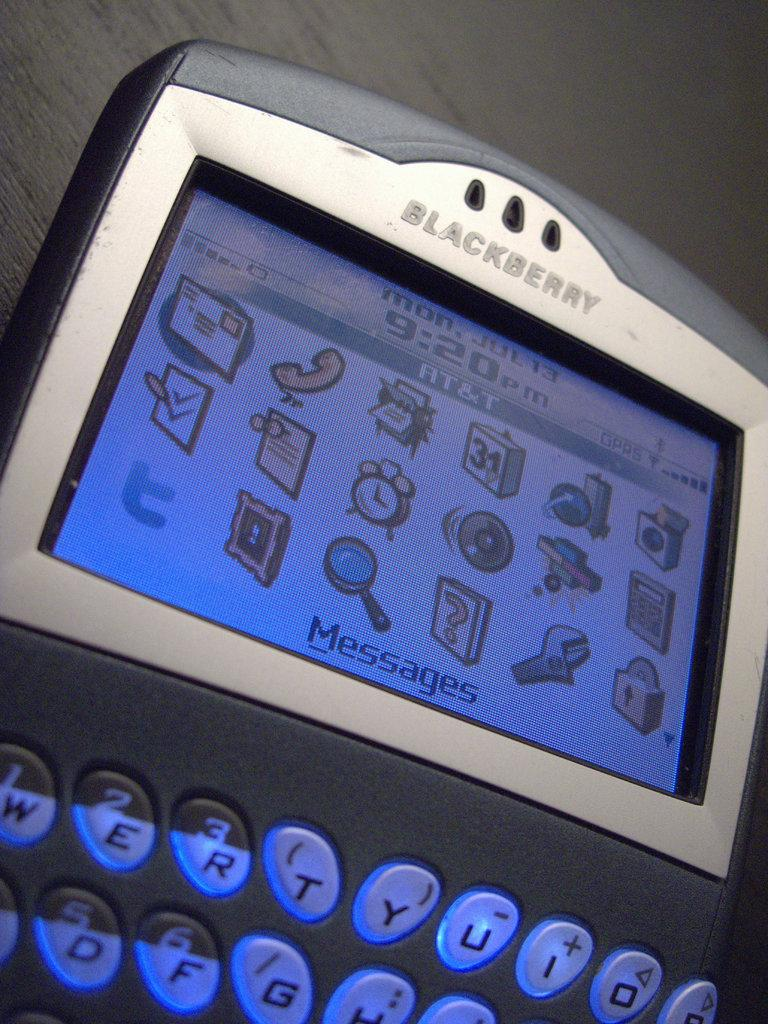What object is the main subject of the image? There is a mobile in the image. Where is the mobile located? The mobile is placed on a table. How many feet are visible in the image? There are no feet present in the image. What type of writing instrument is used by the mobile in the image? The mobile is an inanimate object and cannot use a writing instrument. 